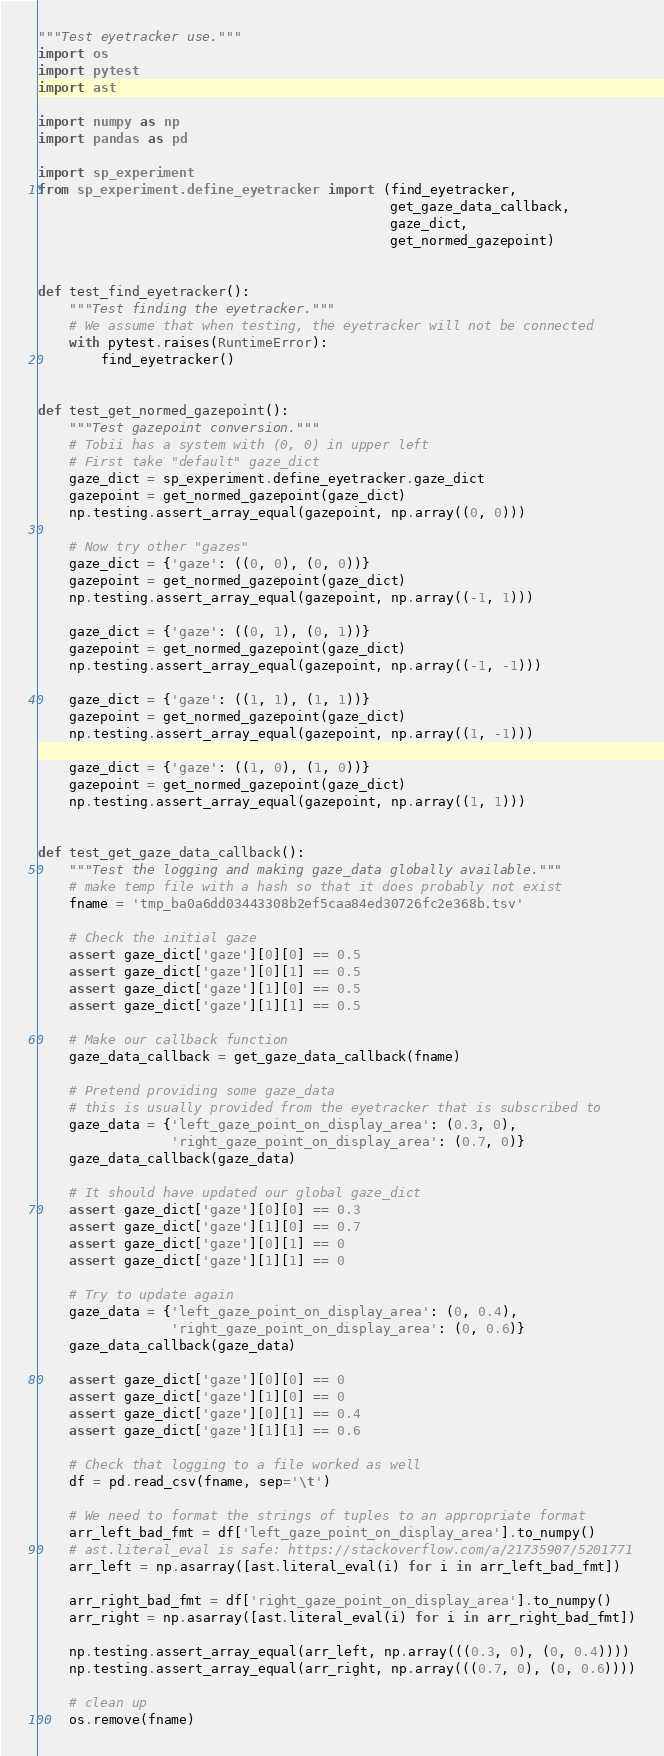<code> <loc_0><loc_0><loc_500><loc_500><_Python_>"""Test eyetracker use."""
import os
import pytest
import ast

import numpy as np
import pandas as pd

import sp_experiment
from sp_experiment.define_eyetracker import (find_eyetracker,
                                             get_gaze_data_callback,
                                             gaze_dict,
                                             get_normed_gazepoint)


def test_find_eyetracker():
    """Test finding the eyetracker."""
    # We assume that when testing, the eyetracker will not be connected
    with pytest.raises(RuntimeError):
        find_eyetracker()


def test_get_normed_gazepoint():
    """Test gazepoint conversion."""
    # Tobii has a system with (0, 0) in upper left
    # First take "default" gaze_dict
    gaze_dict = sp_experiment.define_eyetracker.gaze_dict
    gazepoint = get_normed_gazepoint(gaze_dict)
    np.testing.assert_array_equal(gazepoint, np.array((0, 0)))

    # Now try other "gazes"
    gaze_dict = {'gaze': ((0, 0), (0, 0))}
    gazepoint = get_normed_gazepoint(gaze_dict)
    np.testing.assert_array_equal(gazepoint, np.array((-1, 1)))

    gaze_dict = {'gaze': ((0, 1), (0, 1))}
    gazepoint = get_normed_gazepoint(gaze_dict)
    np.testing.assert_array_equal(gazepoint, np.array((-1, -1)))

    gaze_dict = {'gaze': ((1, 1), (1, 1))}
    gazepoint = get_normed_gazepoint(gaze_dict)
    np.testing.assert_array_equal(gazepoint, np.array((1, -1)))

    gaze_dict = {'gaze': ((1, 0), (1, 0))}
    gazepoint = get_normed_gazepoint(gaze_dict)
    np.testing.assert_array_equal(gazepoint, np.array((1, 1)))


def test_get_gaze_data_callback():
    """Test the logging and making gaze_data globally available."""
    # make temp file with a hash so that it does probably not exist
    fname = 'tmp_ba0a6dd03443308b2ef5caa84ed30726fc2e368b.tsv'

    # Check the initial gaze
    assert gaze_dict['gaze'][0][0] == 0.5
    assert gaze_dict['gaze'][0][1] == 0.5
    assert gaze_dict['gaze'][1][0] == 0.5
    assert gaze_dict['gaze'][1][1] == 0.5

    # Make our callback function
    gaze_data_callback = get_gaze_data_callback(fname)

    # Pretend providing some gaze_data
    # this is usually provided from the eyetracker that is subscribed to
    gaze_data = {'left_gaze_point_on_display_area': (0.3, 0),
                 'right_gaze_point_on_display_area': (0.7, 0)}
    gaze_data_callback(gaze_data)

    # It should have updated our global gaze_dict
    assert gaze_dict['gaze'][0][0] == 0.3
    assert gaze_dict['gaze'][1][0] == 0.7
    assert gaze_dict['gaze'][0][1] == 0
    assert gaze_dict['gaze'][1][1] == 0

    # Try to update again
    gaze_data = {'left_gaze_point_on_display_area': (0, 0.4),
                 'right_gaze_point_on_display_area': (0, 0.6)}
    gaze_data_callback(gaze_data)

    assert gaze_dict['gaze'][0][0] == 0
    assert gaze_dict['gaze'][1][0] == 0
    assert gaze_dict['gaze'][0][1] == 0.4
    assert gaze_dict['gaze'][1][1] == 0.6

    # Check that logging to a file worked as well
    df = pd.read_csv(fname, sep='\t')

    # We need to format the strings of tuples to an appropriate format
    arr_left_bad_fmt = df['left_gaze_point_on_display_area'].to_numpy()
    # ast.literal_eval is safe: https://stackoverflow.com/a/21735907/5201771
    arr_left = np.asarray([ast.literal_eval(i) for i in arr_left_bad_fmt])

    arr_right_bad_fmt = df['right_gaze_point_on_display_area'].to_numpy()
    arr_right = np.asarray([ast.literal_eval(i) for i in arr_right_bad_fmt])

    np.testing.assert_array_equal(arr_left, np.array(((0.3, 0), (0, 0.4))))
    np.testing.assert_array_equal(arr_right, np.array(((0.7, 0), (0, 0.6))))

    # clean up
    os.remove(fname)
</code> 